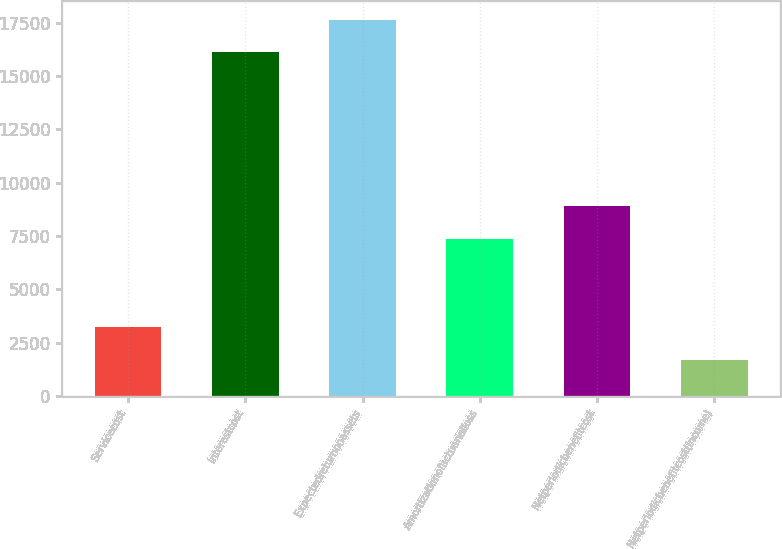<chart> <loc_0><loc_0><loc_500><loc_500><bar_chart><fcel>Servicecost<fcel>Interestcost<fcel>Expectedreturnonassets<fcel>Amortizationofactuarialloss<fcel>Netperiodicbenefitcost<fcel>Netperiodicbenefitcost(income)<nl><fcel>3237.6<fcel>16106<fcel>17636.6<fcel>7361<fcel>8891.6<fcel>1707<nl></chart> 